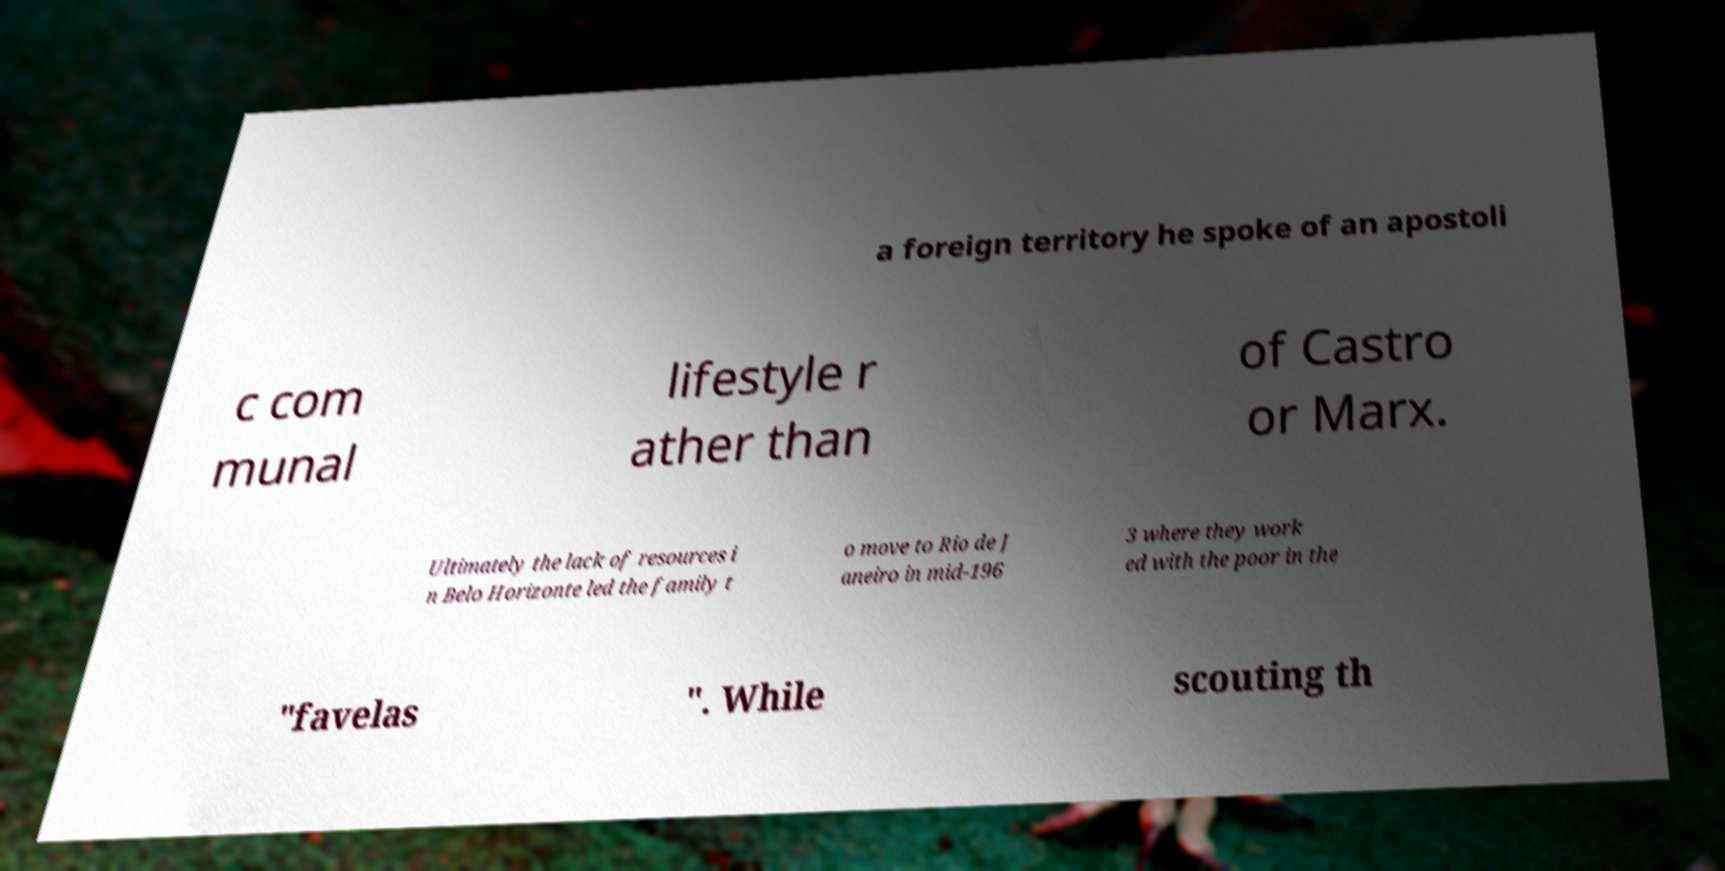Could you extract and type out the text from this image? a foreign territory he spoke of an apostoli c com munal lifestyle r ather than of Castro or Marx. Ultimately the lack of resources i n Belo Horizonte led the family t o move to Rio de J aneiro in mid-196 3 where they work ed with the poor in the "favelas ". While scouting th 